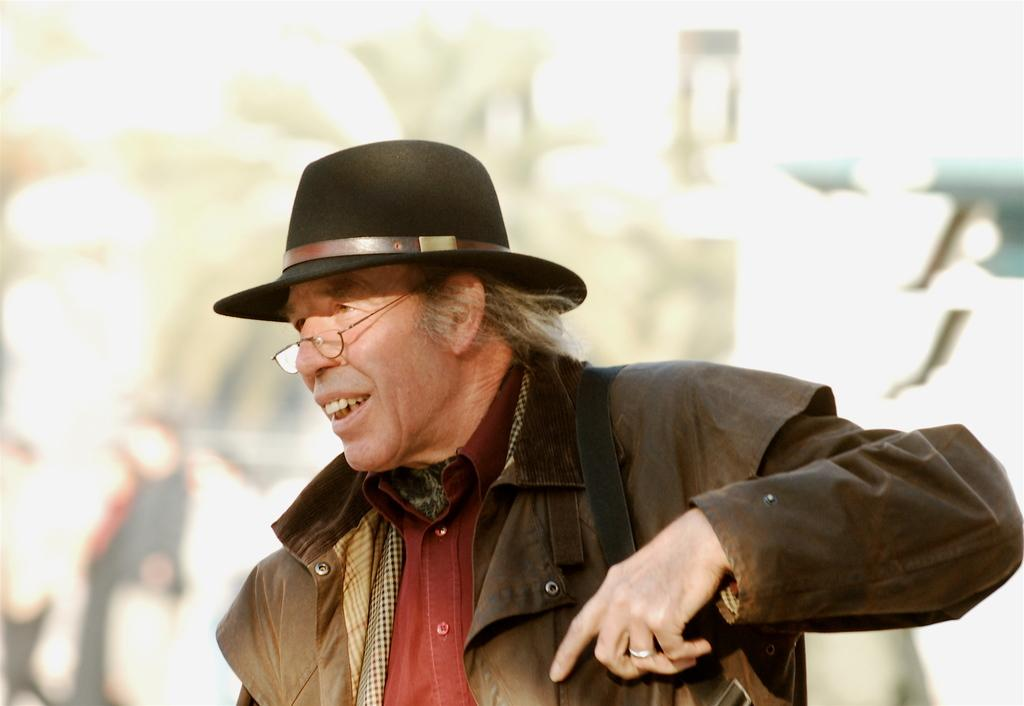Who or what is the main subject in the image? There is a person in the image. What accessories is the person wearing? The person is wearing a cap and spectacles. Can you describe the background of the image? The background of the image is blurred. What type of art is the dog creating in the image? There is no dog or art present in the image; it features a person wearing a cap and spectacles with a blurred background. 